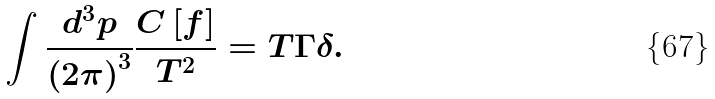Convert formula to latex. <formula><loc_0><loc_0><loc_500><loc_500>\int \frac { d ^ { 3 } p } { \left ( 2 \pi \right ) ^ { 3 } } \frac { C \left [ f \right ] } { T ^ { 2 } } = T \Gamma \delta .</formula> 